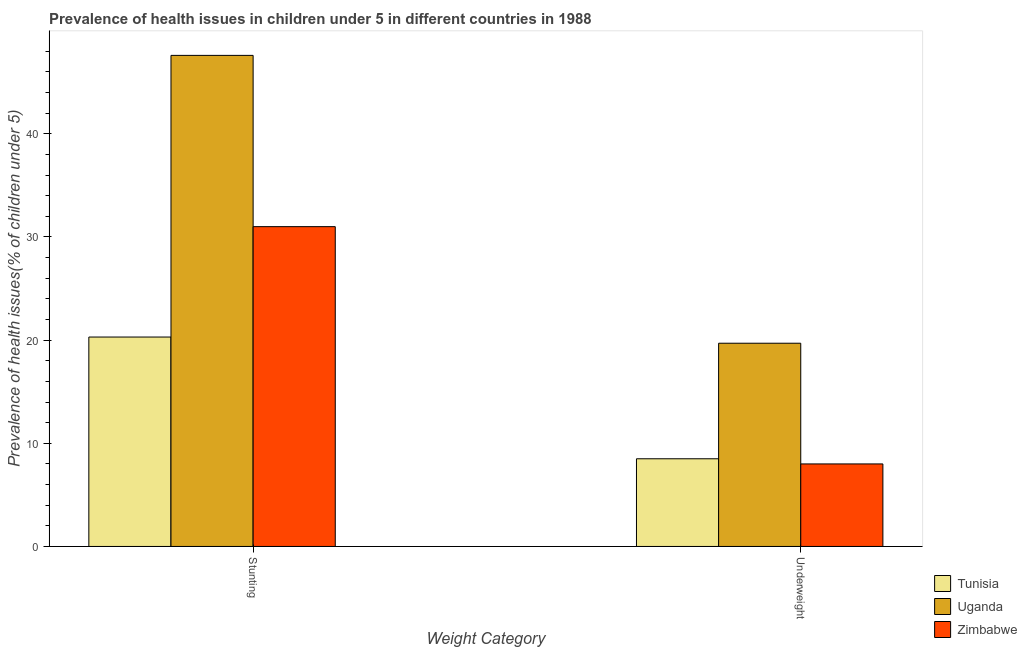How many groups of bars are there?
Your answer should be compact. 2. How many bars are there on the 1st tick from the right?
Ensure brevity in your answer.  3. What is the label of the 2nd group of bars from the left?
Make the answer very short. Underweight. What is the percentage of stunted children in Tunisia?
Offer a very short reply. 20.3. Across all countries, what is the maximum percentage of stunted children?
Keep it short and to the point. 47.6. In which country was the percentage of underweight children maximum?
Provide a succinct answer. Uganda. In which country was the percentage of underweight children minimum?
Keep it short and to the point. Zimbabwe. What is the total percentage of underweight children in the graph?
Your answer should be compact. 36.2. What is the difference between the percentage of underweight children in Uganda and that in Tunisia?
Provide a short and direct response. 11.2. What is the difference between the percentage of underweight children in Uganda and the percentage of stunted children in Zimbabwe?
Ensure brevity in your answer.  -11.3. What is the average percentage of stunted children per country?
Ensure brevity in your answer.  32.97. What is the difference between the percentage of underweight children and percentage of stunted children in Uganda?
Your answer should be very brief. -27.9. What is the ratio of the percentage of stunted children in Uganda to that in Tunisia?
Make the answer very short. 2.34. What does the 2nd bar from the left in Stunting represents?
Make the answer very short. Uganda. What does the 3rd bar from the right in Stunting represents?
Offer a terse response. Tunisia. Are all the bars in the graph horizontal?
Offer a terse response. No. How many countries are there in the graph?
Give a very brief answer. 3. Does the graph contain any zero values?
Offer a very short reply. No. Where does the legend appear in the graph?
Your answer should be very brief. Bottom right. How many legend labels are there?
Ensure brevity in your answer.  3. How are the legend labels stacked?
Offer a very short reply. Vertical. What is the title of the graph?
Your answer should be compact. Prevalence of health issues in children under 5 in different countries in 1988. What is the label or title of the X-axis?
Keep it short and to the point. Weight Category. What is the label or title of the Y-axis?
Your response must be concise. Prevalence of health issues(% of children under 5). What is the Prevalence of health issues(% of children under 5) of Tunisia in Stunting?
Give a very brief answer. 20.3. What is the Prevalence of health issues(% of children under 5) in Uganda in Stunting?
Offer a very short reply. 47.6. What is the Prevalence of health issues(% of children under 5) of Tunisia in Underweight?
Your answer should be compact. 8.5. What is the Prevalence of health issues(% of children under 5) in Uganda in Underweight?
Provide a short and direct response. 19.7. Across all Weight Category, what is the maximum Prevalence of health issues(% of children under 5) of Tunisia?
Give a very brief answer. 20.3. Across all Weight Category, what is the maximum Prevalence of health issues(% of children under 5) in Uganda?
Ensure brevity in your answer.  47.6. Across all Weight Category, what is the minimum Prevalence of health issues(% of children under 5) in Tunisia?
Give a very brief answer. 8.5. Across all Weight Category, what is the minimum Prevalence of health issues(% of children under 5) of Uganda?
Ensure brevity in your answer.  19.7. Across all Weight Category, what is the minimum Prevalence of health issues(% of children under 5) of Zimbabwe?
Your answer should be very brief. 8. What is the total Prevalence of health issues(% of children under 5) in Tunisia in the graph?
Your answer should be very brief. 28.8. What is the total Prevalence of health issues(% of children under 5) in Uganda in the graph?
Give a very brief answer. 67.3. What is the total Prevalence of health issues(% of children under 5) in Zimbabwe in the graph?
Keep it short and to the point. 39. What is the difference between the Prevalence of health issues(% of children under 5) of Uganda in Stunting and that in Underweight?
Make the answer very short. 27.9. What is the difference between the Prevalence of health issues(% of children under 5) of Zimbabwe in Stunting and that in Underweight?
Your answer should be very brief. 23. What is the difference between the Prevalence of health issues(% of children under 5) in Uganda in Stunting and the Prevalence of health issues(% of children under 5) in Zimbabwe in Underweight?
Provide a short and direct response. 39.6. What is the average Prevalence of health issues(% of children under 5) in Tunisia per Weight Category?
Your response must be concise. 14.4. What is the average Prevalence of health issues(% of children under 5) of Uganda per Weight Category?
Offer a very short reply. 33.65. What is the average Prevalence of health issues(% of children under 5) in Zimbabwe per Weight Category?
Keep it short and to the point. 19.5. What is the difference between the Prevalence of health issues(% of children under 5) of Tunisia and Prevalence of health issues(% of children under 5) of Uganda in Stunting?
Give a very brief answer. -27.3. What is the difference between the Prevalence of health issues(% of children under 5) in Tunisia and Prevalence of health issues(% of children under 5) in Zimbabwe in Stunting?
Offer a very short reply. -10.7. What is the difference between the Prevalence of health issues(% of children under 5) of Uganda and Prevalence of health issues(% of children under 5) of Zimbabwe in Stunting?
Provide a short and direct response. 16.6. What is the difference between the Prevalence of health issues(% of children under 5) of Tunisia and Prevalence of health issues(% of children under 5) of Uganda in Underweight?
Offer a terse response. -11.2. What is the difference between the Prevalence of health issues(% of children under 5) of Tunisia and Prevalence of health issues(% of children under 5) of Zimbabwe in Underweight?
Make the answer very short. 0.5. What is the difference between the Prevalence of health issues(% of children under 5) in Uganda and Prevalence of health issues(% of children under 5) in Zimbabwe in Underweight?
Your answer should be very brief. 11.7. What is the ratio of the Prevalence of health issues(% of children under 5) of Tunisia in Stunting to that in Underweight?
Keep it short and to the point. 2.39. What is the ratio of the Prevalence of health issues(% of children under 5) of Uganda in Stunting to that in Underweight?
Your answer should be very brief. 2.42. What is the ratio of the Prevalence of health issues(% of children under 5) of Zimbabwe in Stunting to that in Underweight?
Your response must be concise. 3.88. What is the difference between the highest and the second highest Prevalence of health issues(% of children under 5) of Uganda?
Keep it short and to the point. 27.9. What is the difference between the highest and the lowest Prevalence of health issues(% of children under 5) of Tunisia?
Provide a succinct answer. 11.8. What is the difference between the highest and the lowest Prevalence of health issues(% of children under 5) in Uganda?
Provide a succinct answer. 27.9. What is the difference between the highest and the lowest Prevalence of health issues(% of children under 5) of Zimbabwe?
Your response must be concise. 23. 